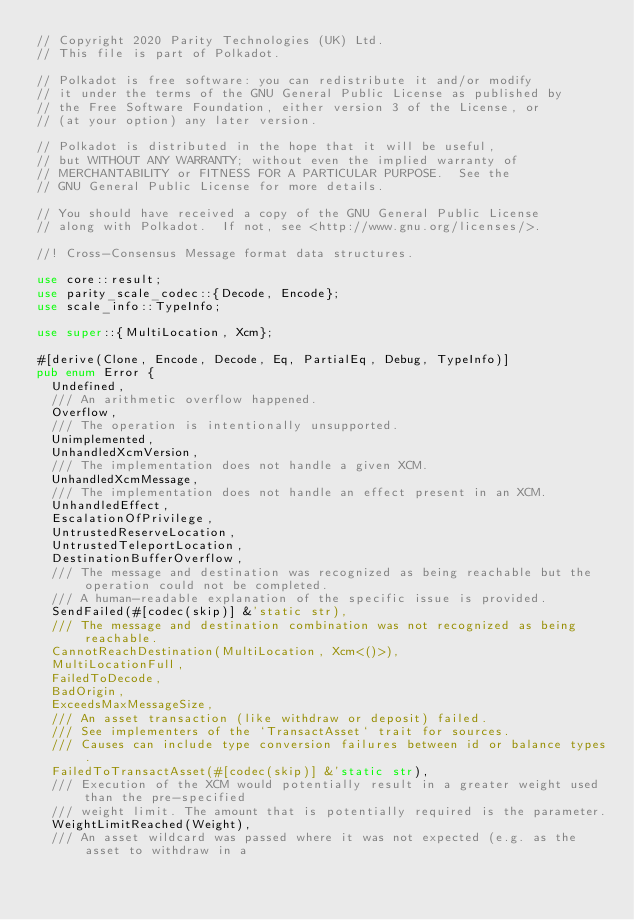<code> <loc_0><loc_0><loc_500><loc_500><_Rust_>// Copyright 2020 Parity Technologies (UK) Ltd.
// This file is part of Polkadot.

// Polkadot is free software: you can redistribute it and/or modify
// it under the terms of the GNU General Public License as published by
// the Free Software Foundation, either version 3 of the License, or
// (at your option) any later version.

// Polkadot is distributed in the hope that it will be useful,
// but WITHOUT ANY WARRANTY; without even the implied warranty of
// MERCHANTABILITY or FITNESS FOR A PARTICULAR PURPOSE.  See the
// GNU General Public License for more details.

// You should have received a copy of the GNU General Public License
// along with Polkadot.  If not, see <http://www.gnu.org/licenses/>.

//! Cross-Consensus Message format data structures.

use core::result;
use parity_scale_codec::{Decode, Encode};
use scale_info::TypeInfo;

use super::{MultiLocation, Xcm};

#[derive(Clone, Encode, Decode, Eq, PartialEq, Debug, TypeInfo)]
pub enum Error {
	Undefined,
	/// An arithmetic overflow happened.
	Overflow,
	/// The operation is intentionally unsupported.
	Unimplemented,
	UnhandledXcmVersion,
	/// The implementation does not handle a given XCM.
	UnhandledXcmMessage,
	/// The implementation does not handle an effect present in an XCM.
	UnhandledEffect,
	EscalationOfPrivilege,
	UntrustedReserveLocation,
	UntrustedTeleportLocation,
	DestinationBufferOverflow,
	/// The message and destination was recognized as being reachable but the operation could not be completed.
	/// A human-readable explanation of the specific issue is provided.
	SendFailed(#[codec(skip)] &'static str),
	/// The message and destination combination was not recognized as being reachable.
	CannotReachDestination(MultiLocation, Xcm<()>),
	MultiLocationFull,
	FailedToDecode,
	BadOrigin,
	ExceedsMaxMessageSize,
	/// An asset transaction (like withdraw or deposit) failed.
	/// See implementers of the `TransactAsset` trait for sources.
	/// Causes can include type conversion failures between id or balance types.
	FailedToTransactAsset(#[codec(skip)] &'static str),
	/// Execution of the XCM would potentially result in a greater weight used than the pre-specified
	/// weight limit. The amount that is potentially required is the parameter.
	WeightLimitReached(Weight),
	/// An asset wildcard was passed where it was not expected (e.g. as the asset to withdraw in a</code> 